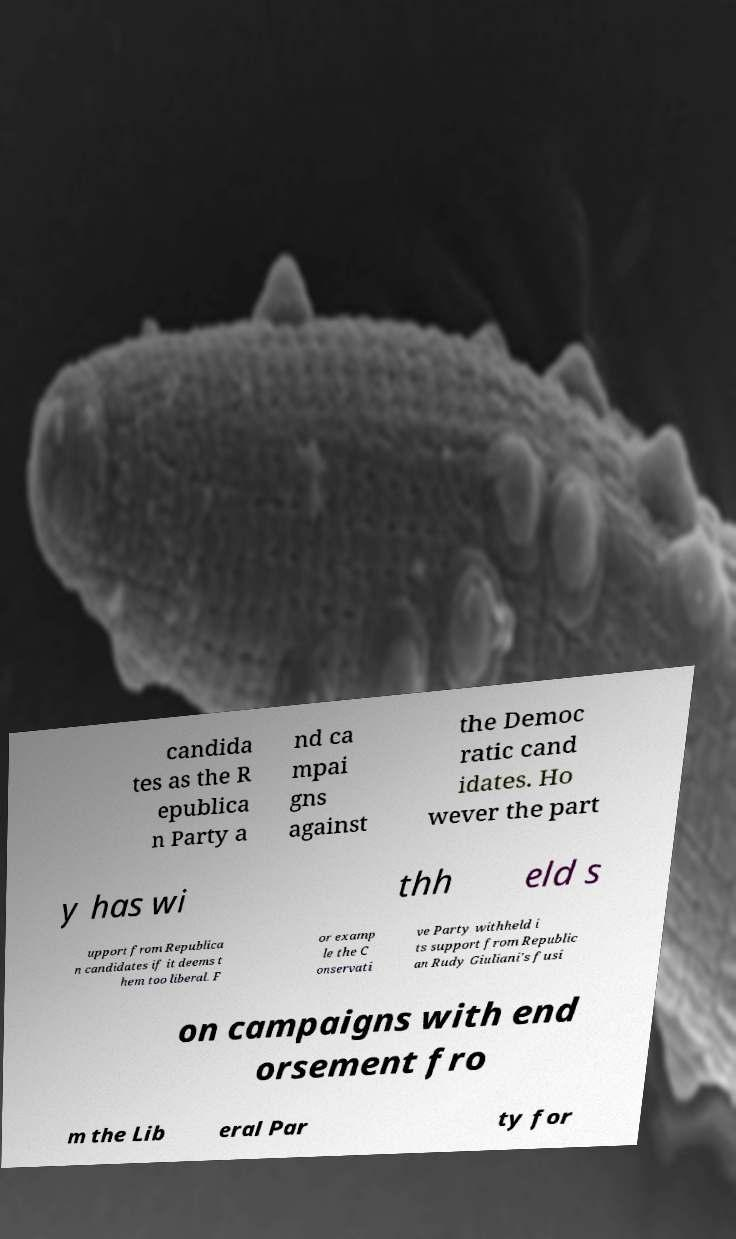Can you accurately transcribe the text from the provided image for me? candida tes as the R epublica n Party a nd ca mpai gns against the Democ ratic cand idates. Ho wever the part y has wi thh eld s upport from Republica n candidates if it deems t hem too liberal. F or examp le the C onservati ve Party withheld i ts support from Republic an Rudy Giuliani's fusi on campaigns with end orsement fro m the Lib eral Par ty for 